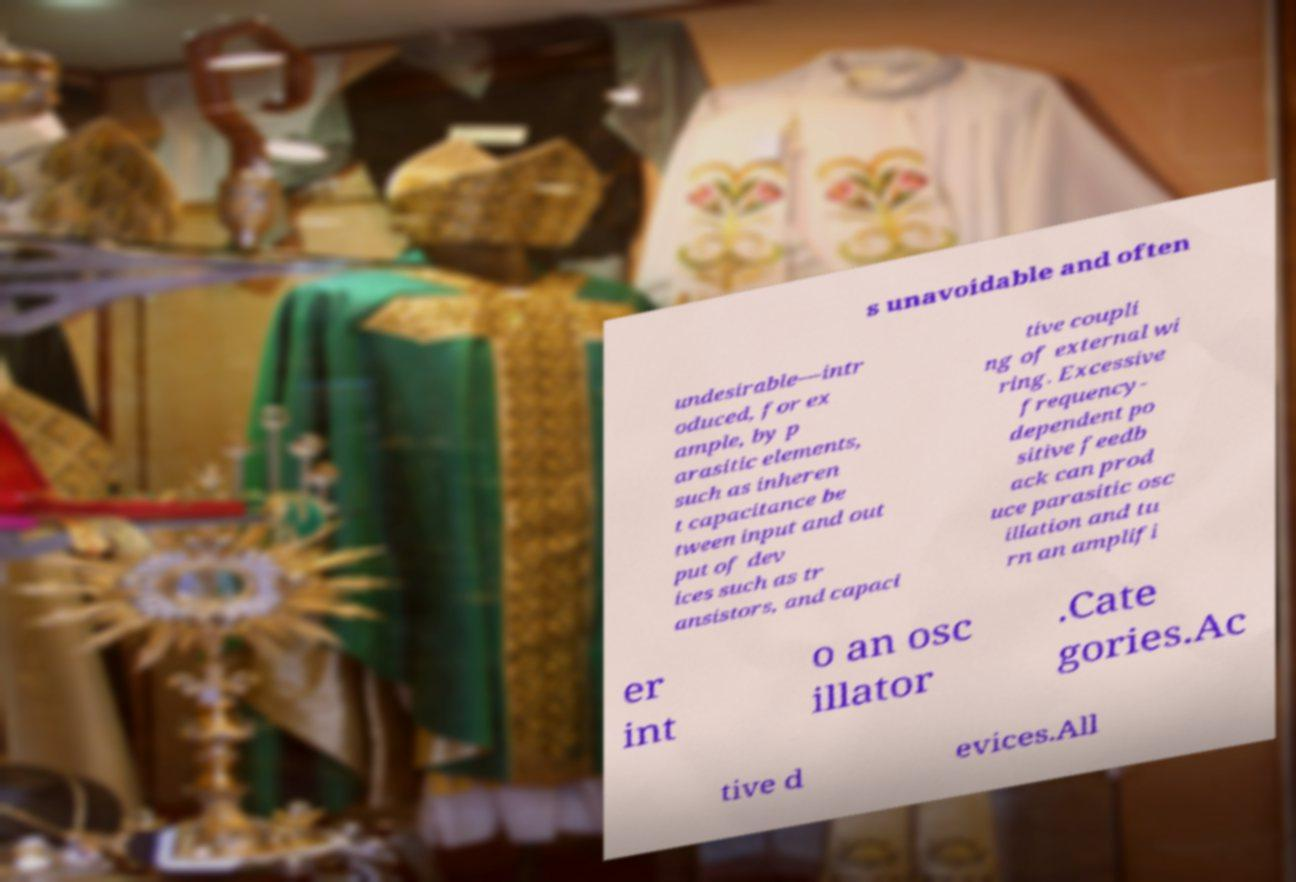Could you assist in decoding the text presented in this image and type it out clearly? s unavoidable and often undesirable—intr oduced, for ex ample, by p arasitic elements, such as inheren t capacitance be tween input and out put of dev ices such as tr ansistors, and capaci tive coupli ng of external wi ring. Excessive frequency- dependent po sitive feedb ack can prod uce parasitic osc illation and tu rn an amplifi er int o an osc illator .Cate gories.Ac tive d evices.All 